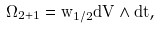Convert formula to latex. <formula><loc_0><loc_0><loc_500><loc_500>\Omega _ { 2 + 1 } = \tilde { w } _ { 1 / 2 } d V \wedge d t ,</formula> 